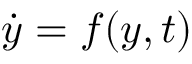<formula> <loc_0><loc_0><loc_500><loc_500>\dot { y } = f ( y , t )</formula> 